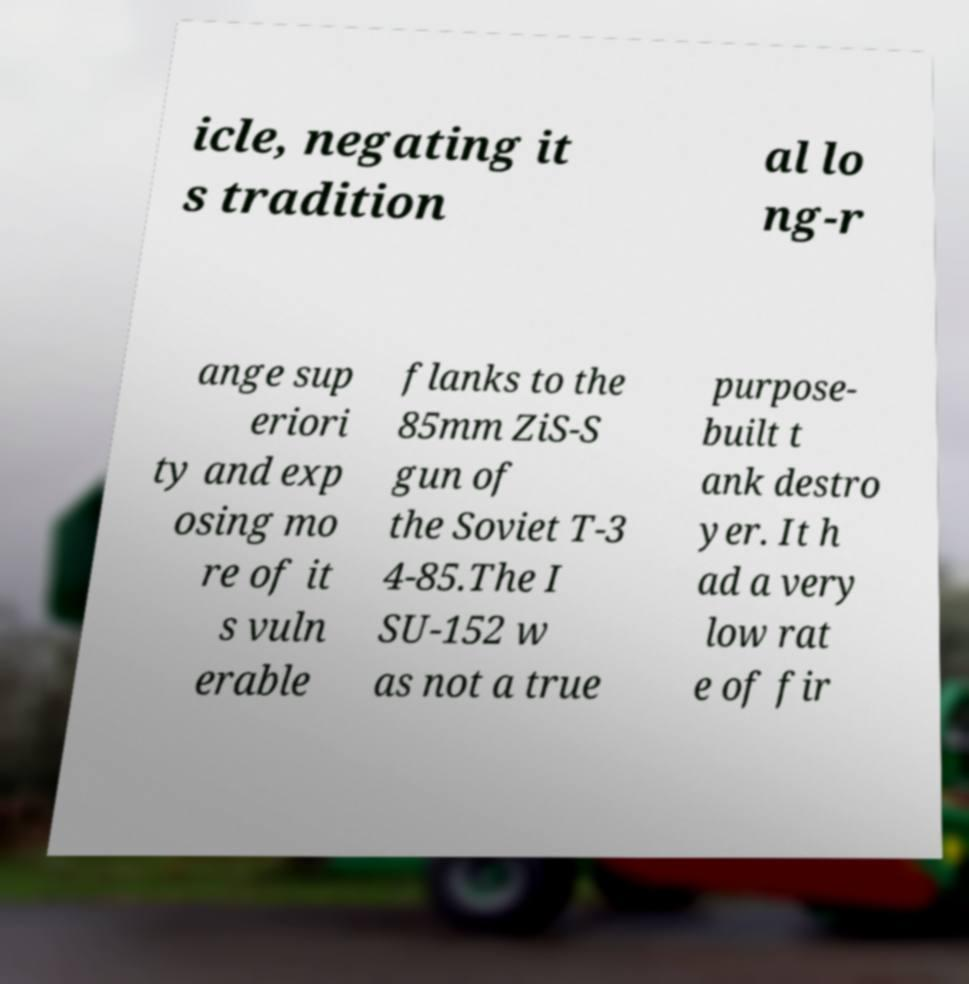What messages or text are displayed in this image? I need them in a readable, typed format. icle, negating it s tradition al lo ng-r ange sup eriori ty and exp osing mo re of it s vuln erable flanks to the 85mm ZiS-S gun of the Soviet T-3 4-85.The I SU-152 w as not a true purpose- built t ank destro yer. It h ad a very low rat e of fir 